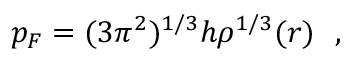Convert formula to latex. <formula><loc_0><loc_0><loc_500><loc_500>p _ { F } = ( 3 { \pi } ^ { 2 } ) ^ { 1 / 3 } h { \rho } ^ { 1 / 3 } ( r ) \ \ ,</formula> 